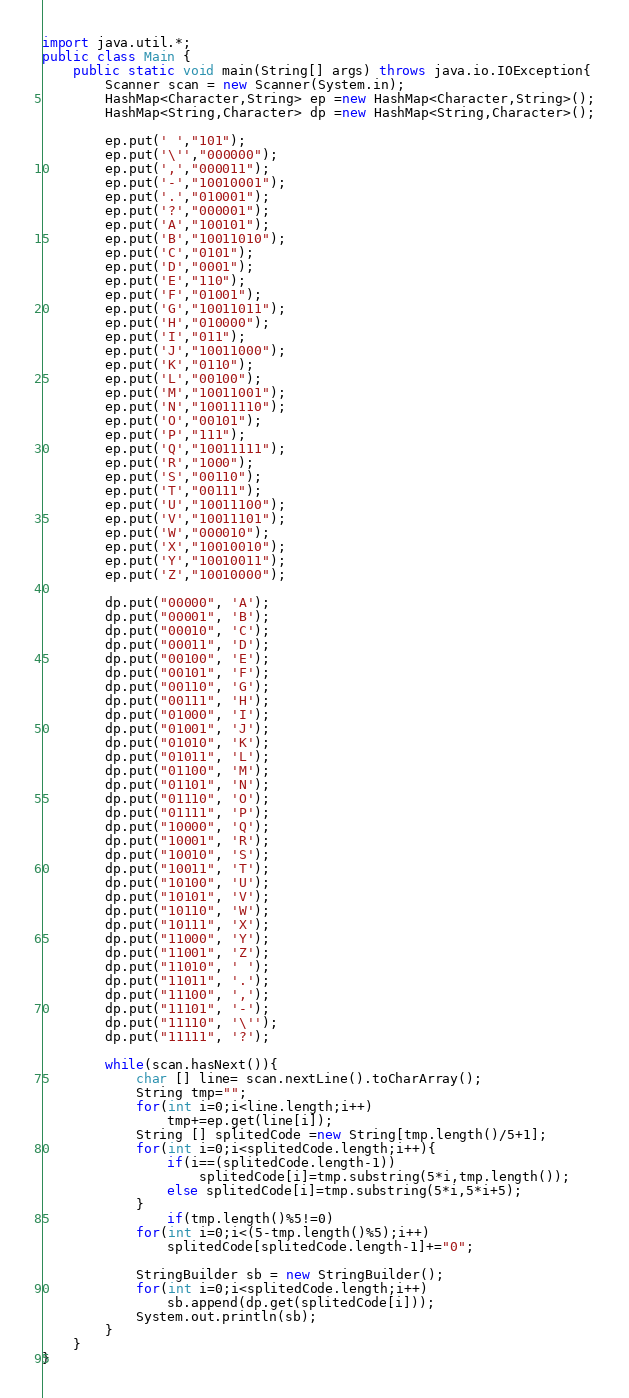Convert code to text. <code><loc_0><loc_0><loc_500><loc_500><_Java_>import java.util.*;
public class Main {
    public static void main(String[] args) throws java.io.IOException{
        Scanner scan = new Scanner(System.in);
        HashMap<Character,String> ep =new HashMap<Character,String>();
        HashMap<String,Character> dp =new HashMap<String,Character>();

        ep.put(' ',"101");
        ep.put('\'',"000000");
        ep.put(',',"000011");
        ep.put('-',"10010001");
        ep.put('.',"010001");
        ep.put('?',"000001");
        ep.put('A',"100101");
        ep.put('B',"10011010");
        ep.put('C',"0101");
        ep.put('D',"0001");
        ep.put('E',"110");
        ep.put('F',"01001");
        ep.put('G',"10011011");
        ep.put('H',"010000");
        ep.put('I',"011");
        ep.put('J',"10011000");
        ep.put('K',"0110");
        ep.put('L',"00100");
        ep.put('M',"10011001");
        ep.put('N',"10011110");
        ep.put('O',"00101");
        ep.put('P',"111");
        ep.put('Q',"10011111");
        ep.put('R',"1000");
        ep.put('S',"00110");
        ep.put('T',"00111");
        ep.put('U',"10011100");
        ep.put('V',"10011101");
        ep.put('W',"000010");
        ep.put('X',"10010010");
        ep.put('Y',"10010011");
        ep.put('Z',"10010000");
        
        dp.put("00000", 'A');
        dp.put("00001", 'B');
        dp.put("00010", 'C');
        dp.put("00011", 'D');
        dp.put("00100", 'E');
        dp.put("00101", 'F');
        dp.put("00110", 'G');
        dp.put("00111", 'H');
        dp.put("01000", 'I');
        dp.put("01001", 'J');
        dp.put("01010", 'K');
        dp.put("01011", 'L');
        dp.put("01100", 'M');
        dp.put("01101", 'N');
        dp.put("01110", 'O');
        dp.put("01111", 'P');
        dp.put("10000", 'Q');
        dp.put("10001", 'R');
        dp.put("10010", 'S');
        dp.put("10011", 'T');
        dp.put("10100", 'U');
        dp.put("10101", 'V');
        dp.put("10110", 'W');
        dp.put("10111", 'X');
        dp.put("11000", 'Y');
        dp.put("11001", 'Z');
        dp.put("11010", ' ');
        dp.put("11011", '.');
        dp.put("11100", ',');
        dp.put("11101", '-');
        dp.put("11110", '\'');
        dp.put("11111", '?');
        
        while(scan.hasNext()){
        	char [] line= scan.nextLine().toCharArray();
        	String tmp="";
        	for(int i=0;i<line.length;i++)
        		tmp+=ep.get(line[i]);
        	String [] splitedCode =new String[tmp.length()/5+1];
        	for(int i=0;i<splitedCode.length;i++){	
        		if(i==(splitedCode.length-1))
        			splitedCode[i]=tmp.substring(5*i,tmp.length());
        		else splitedCode[i]=tmp.substring(5*i,5*i+5);
        	}
        		if(tmp.length()%5!=0)
        	for(int i=0;i<(5-tmp.length()%5);i++)
        		splitedCode[splitedCode.length-1]+="0";
        	
        	StringBuilder sb = new StringBuilder();
        	for(int i=0;i<splitedCode.length;i++)
        		sb.append(dp.get(splitedCode[i]));
        	System.out.println(sb);
        }
    }
}</code> 